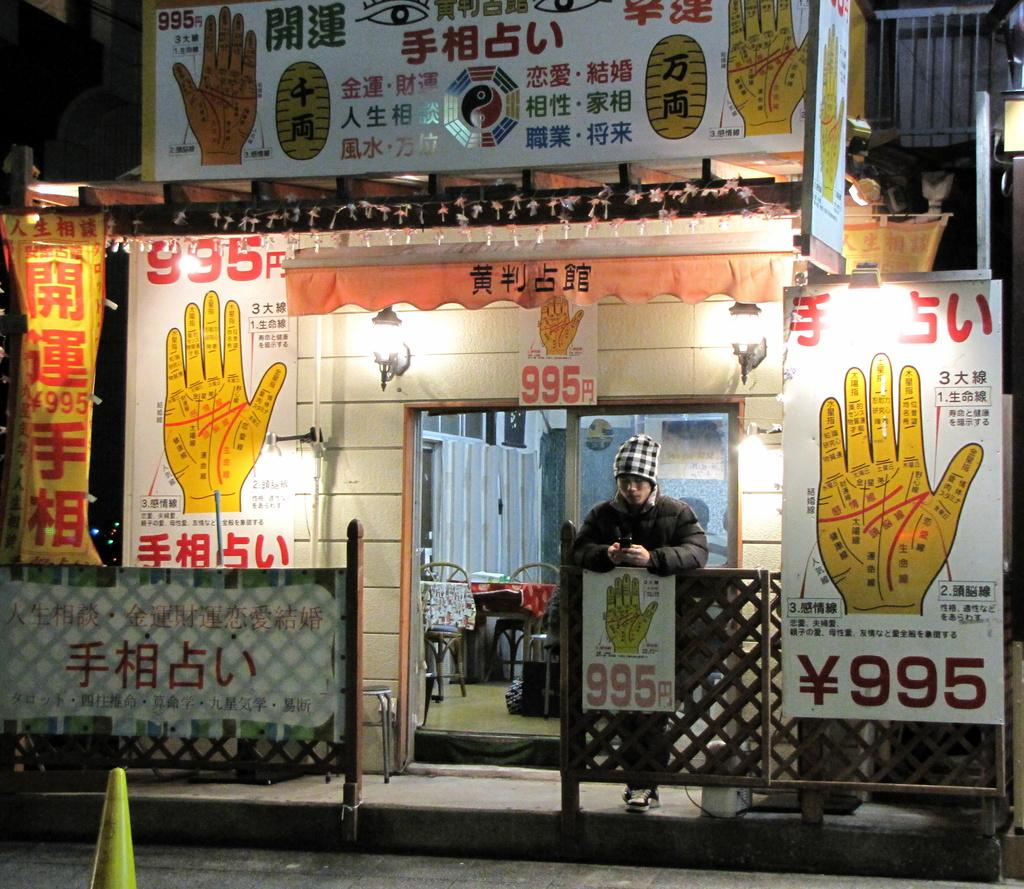What is the main feature of the image? There is a road in the image. What can be seen in the background of the road? There is a shop in the background of the image. What is associated with the shop? There are posters associated with the shop. What is written on the posters? There is text on the posters. What is happening in front of the shop? A person is standing in front of the shop. What type of stamp can be seen on the person's forehead in the image? There is no stamp visible on the person's forehead in the image. 